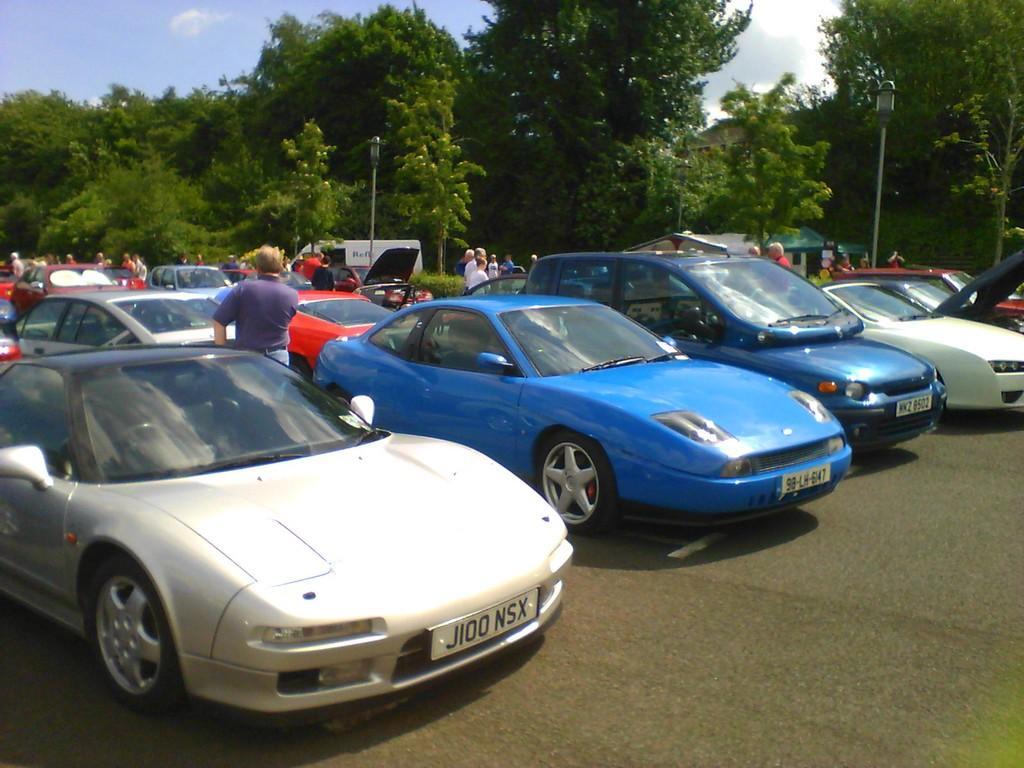Could you give a brief overview of what you see in this image? In the center of the image we can see cars on the road and there are people standing. In the background there are trees, poles and sky. 